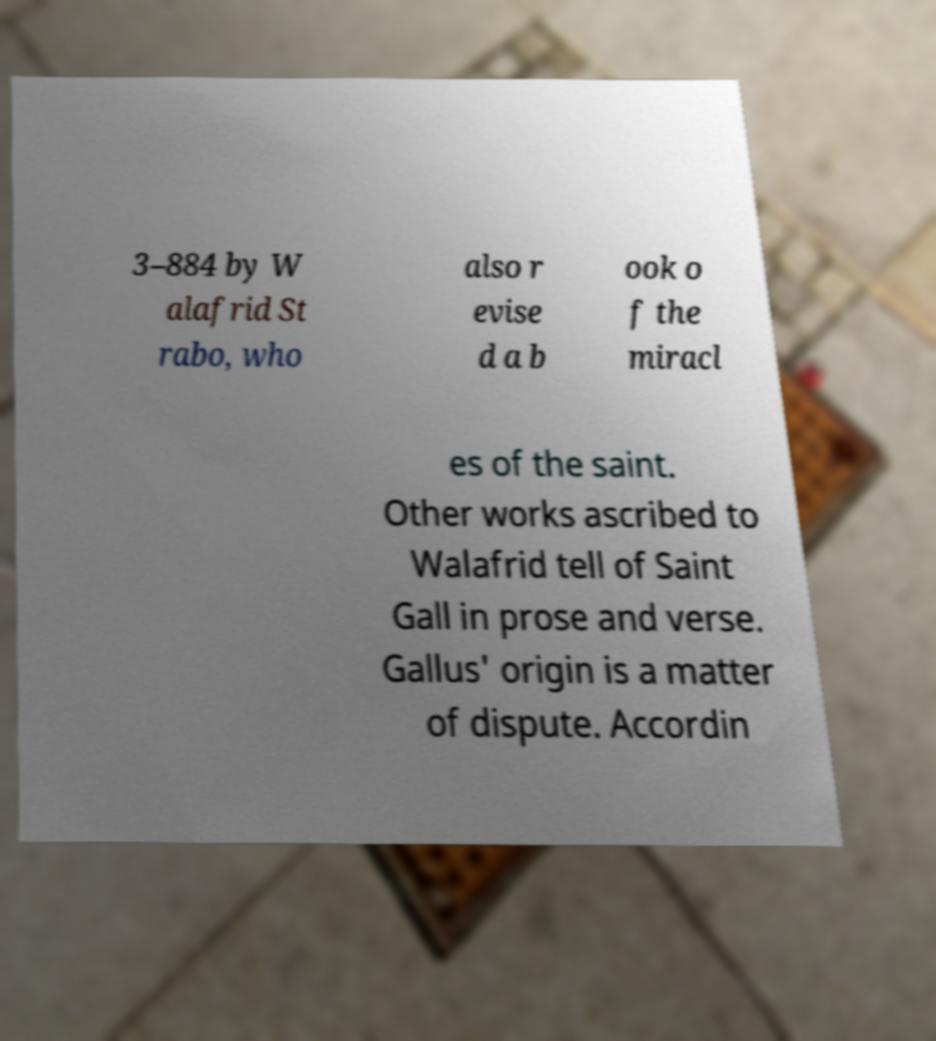Please identify and transcribe the text found in this image. 3–884 by W alafrid St rabo, who also r evise d a b ook o f the miracl es of the saint. Other works ascribed to Walafrid tell of Saint Gall in prose and verse. Gallus' origin is a matter of dispute. Accordin 